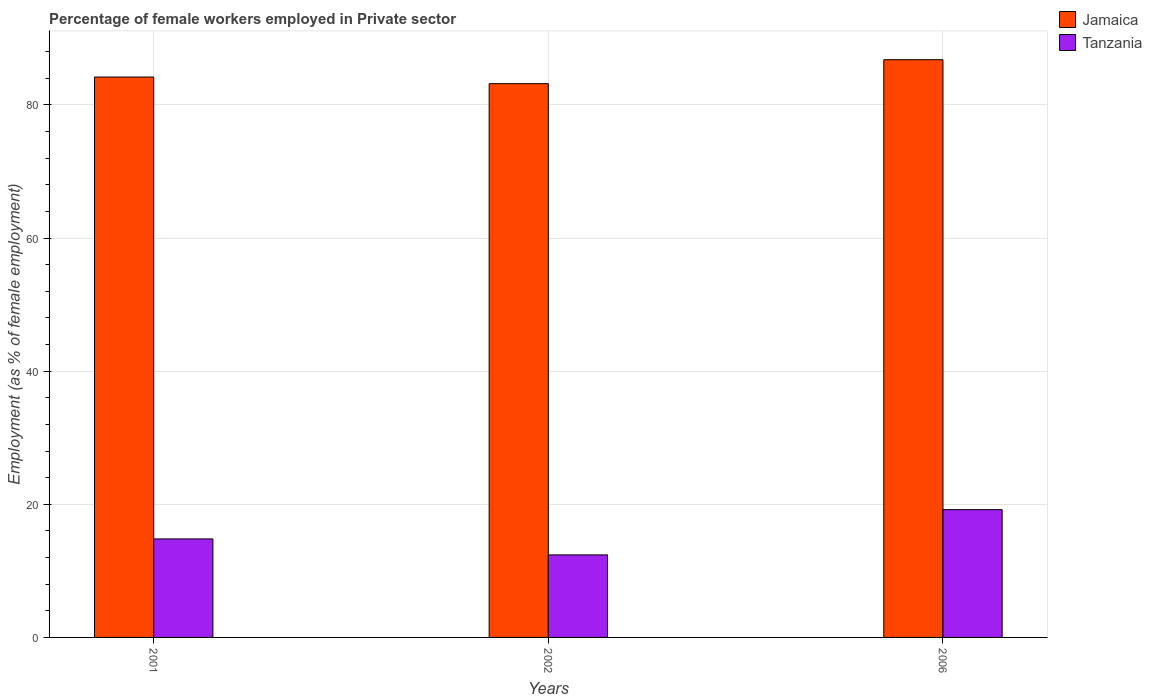How many different coloured bars are there?
Offer a very short reply. 2. How many groups of bars are there?
Offer a terse response. 3. Are the number of bars per tick equal to the number of legend labels?
Provide a short and direct response. Yes. How many bars are there on the 2nd tick from the left?
Your response must be concise. 2. How many bars are there on the 2nd tick from the right?
Offer a terse response. 2. What is the percentage of females employed in Private sector in Jamaica in 2006?
Offer a very short reply. 86.8. Across all years, what is the maximum percentage of females employed in Private sector in Jamaica?
Make the answer very short. 86.8. Across all years, what is the minimum percentage of females employed in Private sector in Jamaica?
Ensure brevity in your answer.  83.2. What is the total percentage of females employed in Private sector in Tanzania in the graph?
Offer a terse response. 46.4. What is the difference between the percentage of females employed in Private sector in Tanzania in 2001 and that in 2006?
Ensure brevity in your answer.  -4.4. What is the difference between the percentage of females employed in Private sector in Tanzania in 2001 and the percentage of females employed in Private sector in Jamaica in 2006?
Provide a short and direct response. -72. What is the average percentage of females employed in Private sector in Jamaica per year?
Provide a short and direct response. 84.73. In the year 2001, what is the difference between the percentage of females employed in Private sector in Jamaica and percentage of females employed in Private sector in Tanzania?
Provide a succinct answer. 69.4. In how many years, is the percentage of females employed in Private sector in Tanzania greater than 24 %?
Make the answer very short. 0. What is the ratio of the percentage of females employed in Private sector in Jamaica in 2002 to that in 2006?
Give a very brief answer. 0.96. Is the percentage of females employed in Private sector in Tanzania in 2001 less than that in 2006?
Make the answer very short. Yes. Is the difference between the percentage of females employed in Private sector in Jamaica in 2001 and 2002 greater than the difference between the percentage of females employed in Private sector in Tanzania in 2001 and 2002?
Your response must be concise. No. What is the difference between the highest and the second highest percentage of females employed in Private sector in Tanzania?
Give a very brief answer. 4.4. What is the difference between the highest and the lowest percentage of females employed in Private sector in Tanzania?
Offer a terse response. 6.8. Is the sum of the percentage of females employed in Private sector in Jamaica in 2001 and 2002 greater than the maximum percentage of females employed in Private sector in Tanzania across all years?
Provide a short and direct response. Yes. What does the 2nd bar from the left in 2002 represents?
Offer a very short reply. Tanzania. What does the 2nd bar from the right in 2001 represents?
Your answer should be very brief. Jamaica. How many bars are there?
Ensure brevity in your answer.  6. Are the values on the major ticks of Y-axis written in scientific E-notation?
Give a very brief answer. No. Does the graph contain any zero values?
Your answer should be very brief. No. What is the title of the graph?
Your answer should be very brief. Percentage of female workers employed in Private sector. Does "Chile" appear as one of the legend labels in the graph?
Give a very brief answer. No. What is the label or title of the X-axis?
Offer a terse response. Years. What is the label or title of the Y-axis?
Give a very brief answer. Employment (as % of female employment). What is the Employment (as % of female employment) in Jamaica in 2001?
Offer a terse response. 84.2. What is the Employment (as % of female employment) of Tanzania in 2001?
Make the answer very short. 14.8. What is the Employment (as % of female employment) in Jamaica in 2002?
Your answer should be very brief. 83.2. What is the Employment (as % of female employment) of Tanzania in 2002?
Offer a terse response. 12.4. What is the Employment (as % of female employment) of Jamaica in 2006?
Your response must be concise. 86.8. What is the Employment (as % of female employment) of Tanzania in 2006?
Make the answer very short. 19.2. Across all years, what is the maximum Employment (as % of female employment) in Jamaica?
Your response must be concise. 86.8. Across all years, what is the maximum Employment (as % of female employment) in Tanzania?
Your answer should be compact. 19.2. Across all years, what is the minimum Employment (as % of female employment) in Jamaica?
Ensure brevity in your answer.  83.2. Across all years, what is the minimum Employment (as % of female employment) of Tanzania?
Your response must be concise. 12.4. What is the total Employment (as % of female employment) in Jamaica in the graph?
Keep it short and to the point. 254.2. What is the total Employment (as % of female employment) in Tanzania in the graph?
Make the answer very short. 46.4. What is the difference between the Employment (as % of female employment) in Jamaica in 2001 and that in 2002?
Your answer should be compact. 1. What is the difference between the Employment (as % of female employment) of Tanzania in 2001 and that in 2002?
Offer a very short reply. 2.4. What is the difference between the Employment (as % of female employment) of Tanzania in 2001 and that in 2006?
Offer a very short reply. -4.4. What is the difference between the Employment (as % of female employment) in Tanzania in 2002 and that in 2006?
Ensure brevity in your answer.  -6.8. What is the difference between the Employment (as % of female employment) of Jamaica in 2001 and the Employment (as % of female employment) of Tanzania in 2002?
Your answer should be compact. 71.8. What is the difference between the Employment (as % of female employment) of Jamaica in 2002 and the Employment (as % of female employment) of Tanzania in 2006?
Offer a very short reply. 64. What is the average Employment (as % of female employment) in Jamaica per year?
Keep it short and to the point. 84.73. What is the average Employment (as % of female employment) of Tanzania per year?
Provide a short and direct response. 15.47. In the year 2001, what is the difference between the Employment (as % of female employment) in Jamaica and Employment (as % of female employment) in Tanzania?
Offer a terse response. 69.4. In the year 2002, what is the difference between the Employment (as % of female employment) of Jamaica and Employment (as % of female employment) of Tanzania?
Offer a terse response. 70.8. In the year 2006, what is the difference between the Employment (as % of female employment) of Jamaica and Employment (as % of female employment) of Tanzania?
Your answer should be compact. 67.6. What is the ratio of the Employment (as % of female employment) of Tanzania in 2001 to that in 2002?
Give a very brief answer. 1.19. What is the ratio of the Employment (as % of female employment) in Tanzania in 2001 to that in 2006?
Keep it short and to the point. 0.77. What is the ratio of the Employment (as % of female employment) of Jamaica in 2002 to that in 2006?
Make the answer very short. 0.96. What is the ratio of the Employment (as % of female employment) in Tanzania in 2002 to that in 2006?
Ensure brevity in your answer.  0.65. What is the difference between the highest and the second highest Employment (as % of female employment) of Jamaica?
Offer a very short reply. 2.6. What is the difference between the highest and the lowest Employment (as % of female employment) of Jamaica?
Give a very brief answer. 3.6. 